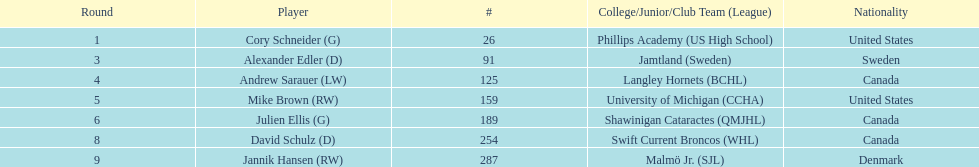What is the name of the last player on this chart? Jannik Hansen (RW). 